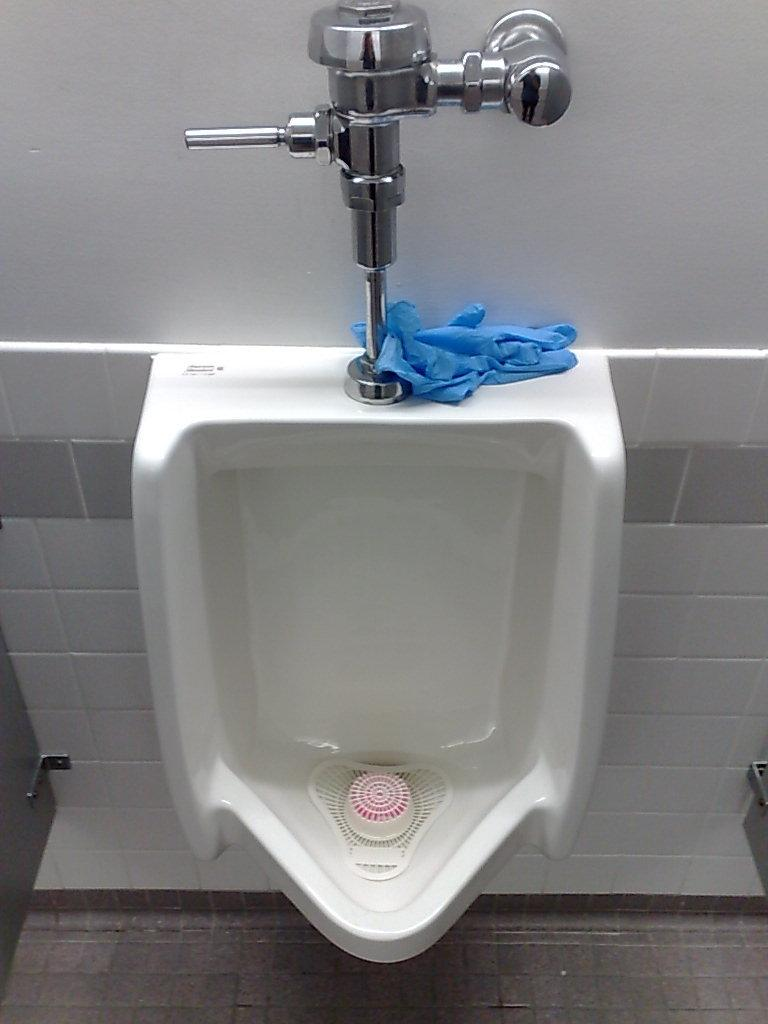What is the main object in the center of the image? There is a urinal in the middle of the image. What is the material of the water supply arrangement on the wall? The water supply arrangement on the wall is made of stainless steel. What type of plant can be seen growing inside the urinal in the image? There are no plants visible inside the urinal in the image. 